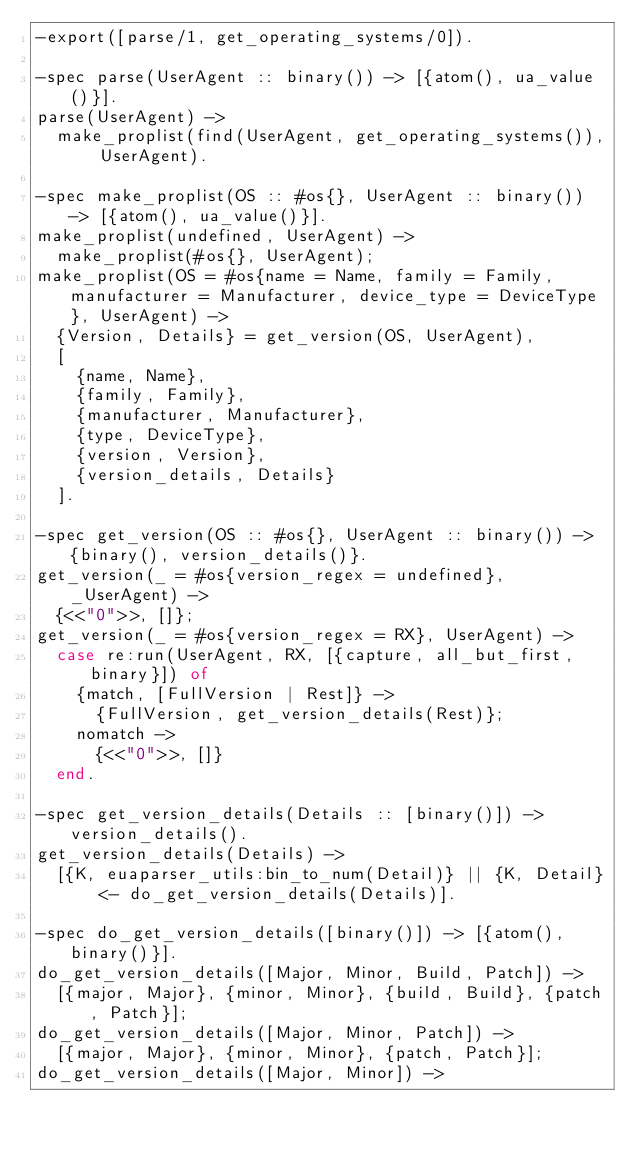<code> <loc_0><loc_0><loc_500><loc_500><_Erlang_>-export([parse/1, get_operating_systems/0]).

-spec parse(UserAgent :: binary()) -> [{atom(), ua_value()}].
parse(UserAgent) ->
  make_proplist(find(UserAgent, get_operating_systems()), UserAgent).

-spec make_proplist(OS :: #os{}, UserAgent :: binary()) -> [{atom(), ua_value()}].
make_proplist(undefined, UserAgent) ->
  make_proplist(#os{}, UserAgent);
make_proplist(OS = #os{name = Name, family = Family, manufacturer = Manufacturer, device_type = DeviceType}, UserAgent) ->
  {Version, Details} = get_version(OS, UserAgent),
  [
    {name, Name},
    {family, Family},
    {manufacturer, Manufacturer},
    {type, DeviceType},
    {version, Version},
    {version_details, Details}
  ].

-spec get_version(OS :: #os{}, UserAgent :: binary()) -> {binary(), version_details()}.
get_version(_ = #os{version_regex = undefined}, _UserAgent) ->
  {<<"0">>, []};
get_version(_ = #os{version_regex = RX}, UserAgent) ->
  case re:run(UserAgent, RX, [{capture, all_but_first, binary}]) of
    {match, [FullVersion | Rest]} ->
      {FullVersion, get_version_details(Rest)};
    nomatch ->
      {<<"0">>, []}
  end.

-spec get_version_details(Details :: [binary()]) -> version_details().
get_version_details(Details) ->
  [{K, euaparser_utils:bin_to_num(Detail)} || {K, Detail} <- do_get_version_details(Details)].

-spec do_get_version_details([binary()]) -> [{atom(), binary()}].
do_get_version_details([Major, Minor, Build, Patch]) ->
  [{major, Major}, {minor, Minor}, {build, Build}, {patch, Patch}];
do_get_version_details([Major, Minor, Patch]) ->
  [{major, Major}, {minor, Minor}, {patch, Patch}];
do_get_version_details([Major, Minor]) -></code> 